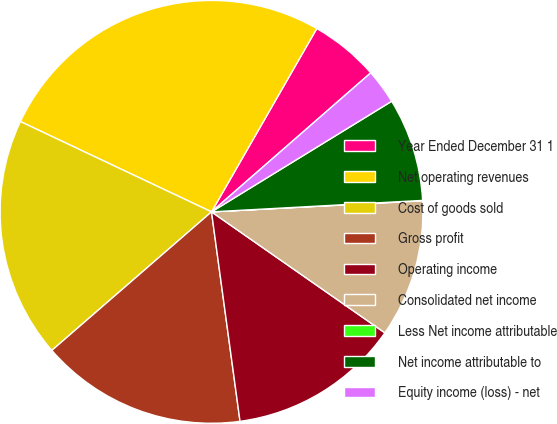Convert chart. <chart><loc_0><loc_0><loc_500><loc_500><pie_chart><fcel>Year Ended December 31 1<fcel>Net operating revenues<fcel>Cost of goods sold<fcel>Gross profit<fcel>Operating income<fcel>Consolidated net income<fcel>Less Net income attributable<fcel>Net income attributable to<fcel>Equity income (loss) - net<nl><fcel>5.28%<fcel>26.27%<fcel>18.4%<fcel>15.78%<fcel>13.15%<fcel>10.53%<fcel>0.03%<fcel>7.9%<fcel>2.66%<nl></chart> 